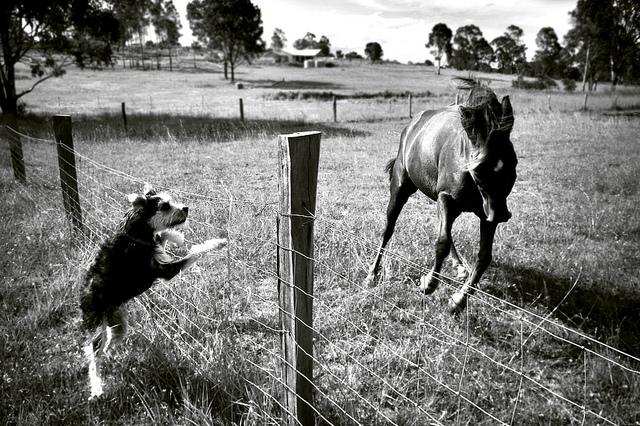How are the dogs kept close?
Short answer required. Fence. What kind of animal is touching the fence?
Be succinct. Dog. In which season does this scene take place?
Be succinct. Spring. Is the dog jumping over the fence?
Short answer required. No. What kind of dog is in the background?
Concise answer only. Terrier. Is the image in black and white?
Concise answer only. Yes. 